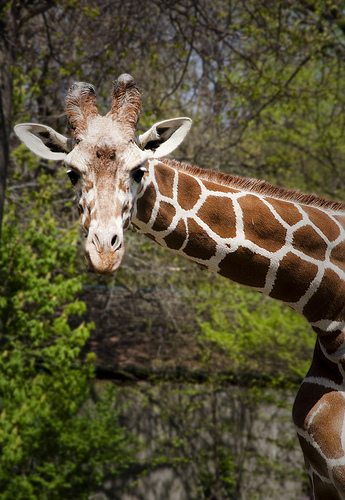<image>
Is the giraffe on the trees? No. The giraffe is not positioned on the trees. They may be near each other, but the giraffe is not supported by or resting on top of the trees. 